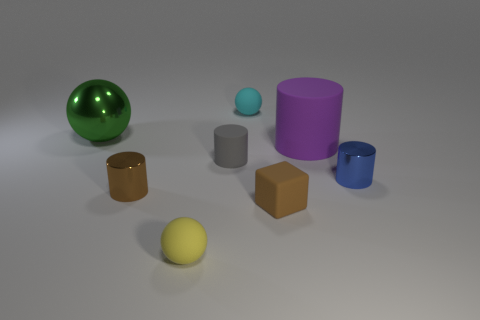Subtract all purple rubber cylinders. How many cylinders are left? 3 Add 1 gray rubber balls. How many objects exist? 9 Subtract all cyan spheres. How many spheres are left? 2 Subtract all blocks. How many objects are left? 7 Add 2 brown rubber objects. How many brown rubber objects exist? 3 Subtract 0 red blocks. How many objects are left? 8 Subtract 2 cylinders. How many cylinders are left? 2 Subtract all green cylinders. Subtract all brown balls. How many cylinders are left? 4 Subtract all brown objects. Subtract all yellow things. How many objects are left? 5 Add 2 tiny blue objects. How many tiny blue objects are left? 3 